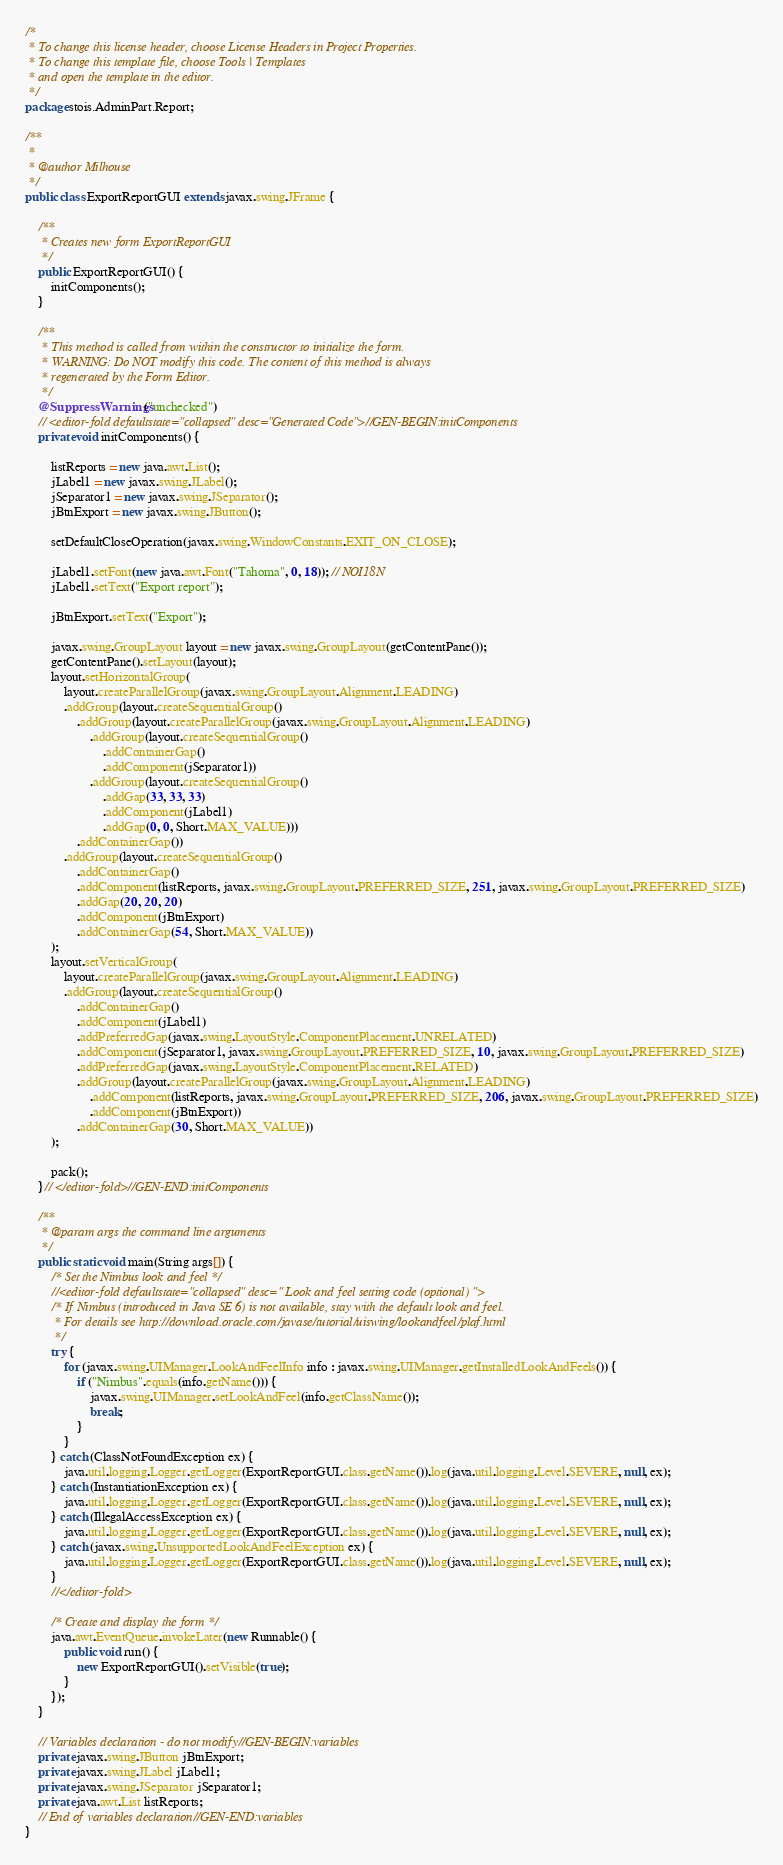<code> <loc_0><loc_0><loc_500><loc_500><_Java_>/*
 * To change this license header, choose License Headers in Project Properties.
 * To change this template file, choose Tools | Templates
 * and open the template in the editor.
 */
package stois.AdminPart.Report;

/**
 *
 * @author Milhouse
 */
public class ExportReportGUI extends javax.swing.JFrame {

    /**
     * Creates new form ExportReportGUI
     */
    public ExportReportGUI() {
        initComponents();
    }

    /**
     * This method is called from within the constructor to initialize the form.
     * WARNING: Do NOT modify this code. The content of this method is always
     * regenerated by the Form Editor.
     */
    @SuppressWarnings("unchecked")
    // <editor-fold defaultstate="collapsed" desc="Generated Code">//GEN-BEGIN:initComponents
    private void initComponents() {

        listReports = new java.awt.List();
        jLabel1 = new javax.swing.JLabel();
        jSeparator1 = new javax.swing.JSeparator();
        jBtnExport = new javax.swing.JButton();

        setDefaultCloseOperation(javax.swing.WindowConstants.EXIT_ON_CLOSE);

        jLabel1.setFont(new java.awt.Font("Tahoma", 0, 18)); // NOI18N
        jLabel1.setText("Export report");

        jBtnExport.setText("Export");

        javax.swing.GroupLayout layout = new javax.swing.GroupLayout(getContentPane());
        getContentPane().setLayout(layout);
        layout.setHorizontalGroup(
            layout.createParallelGroup(javax.swing.GroupLayout.Alignment.LEADING)
            .addGroup(layout.createSequentialGroup()
                .addGroup(layout.createParallelGroup(javax.swing.GroupLayout.Alignment.LEADING)
                    .addGroup(layout.createSequentialGroup()
                        .addContainerGap()
                        .addComponent(jSeparator1))
                    .addGroup(layout.createSequentialGroup()
                        .addGap(33, 33, 33)
                        .addComponent(jLabel1)
                        .addGap(0, 0, Short.MAX_VALUE)))
                .addContainerGap())
            .addGroup(layout.createSequentialGroup()
                .addContainerGap()
                .addComponent(listReports, javax.swing.GroupLayout.PREFERRED_SIZE, 251, javax.swing.GroupLayout.PREFERRED_SIZE)
                .addGap(20, 20, 20)
                .addComponent(jBtnExport)
                .addContainerGap(54, Short.MAX_VALUE))
        );
        layout.setVerticalGroup(
            layout.createParallelGroup(javax.swing.GroupLayout.Alignment.LEADING)
            .addGroup(layout.createSequentialGroup()
                .addContainerGap()
                .addComponent(jLabel1)
                .addPreferredGap(javax.swing.LayoutStyle.ComponentPlacement.UNRELATED)
                .addComponent(jSeparator1, javax.swing.GroupLayout.PREFERRED_SIZE, 10, javax.swing.GroupLayout.PREFERRED_SIZE)
                .addPreferredGap(javax.swing.LayoutStyle.ComponentPlacement.RELATED)
                .addGroup(layout.createParallelGroup(javax.swing.GroupLayout.Alignment.LEADING)
                    .addComponent(listReports, javax.swing.GroupLayout.PREFERRED_SIZE, 206, javax.swing.GroupLayout.PREFERRED_SIZE)
                    .addComponent(jBtnExport))
                .addContainerGap(30, Short.MAX_VALUE))
        );

        pack();
    }// </editor-fold>//GEN-END:initComponents

    /**
     * @param args the command line arguments
     */
    public static void main(String args[]) {
        /* Set the Nimbus look and feel */
        //<editor-fold defaultstate="collapsed" desc=" Look and feel setting code (optional) ">
        /* If Nimbus (introduced in Java SE 6) is not available, stay with the default look and feel.
         * For details see http://download.oracle.com/javase/tutorial/uiswing/lookandfeel/plaf.html 
         */
        try {
            for (javax.swing.UIManager.LookAndFeelInfo info : javax.swing.UIManager.getInstalledLookAndFeels()) {
                if ("Nimbus".equals(info.getName())) {
                    javax.swing.UIManager.setLookAndFeel(info.getClassName());
                    break;
                }
            }
        } catch (ClassNotFoundException ex) {
            java.util.logging.Logger.getLogger(ExportReportGUI.class.getName()).log(java.util.logging.Level.SEVERE, null, ex);
        } catch (InstantiationException ex) {
            java.util.logging.Logger.getLogger(ExportReportGUI.class.getName()).log(java.util.logging.Level.SEVERE, null, ex);
        } catch (IllegalAccessException ex) {
            java.util.logging.Logger.getLogger(ExportReportGUI.class.getName()).log(java.util.logging.Level.SEVERE, null, ex);
        } catch (javax.swing.UnsupportedLookAndFeelException ex) {
            java.util.logging.Logger.getLogger(ExportReportGUI.class.getName()).log(java.util.logging.Level.SEVERE, null, ex);
        }
        //</editor-fold>

        /* Create and display the form */
        java.awt.EventQueue.invokeLater(new Runnable() {
            public void run() {
                new ExportReportGUI().setVisible(true);
            }
        });
    }

    // Variables declaration - do not modify//GEN-BEGIN:variables
    private javax.swing.JButton jBtnExport;
    private javax.swing.JLabel jLabel1;
    private javax.swing.JSeparator jSeparator1;
    private java.awt.List listReports;
    // End of variables declaration//GEN-END:variables
}
</code> 